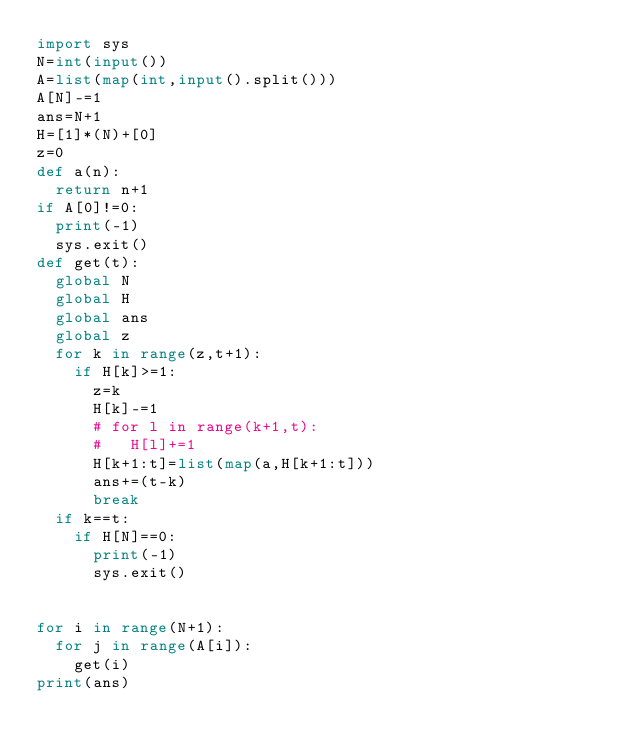<code> <loc_0><loc_0><loc_500><loc_500><_Python_>import sys
N=int(input())
A=list(map(int,input().split()))
A[N]-=1
ans=N+1
H=[1]*(N)+[0]
z=0
def a(n):
  return n+1
if A[0]!=0:
  print(-1)
  sys.exit()
def get(t):
  global N
  global H
  global ans
  global z
  for k in range(z,t+1):
    if H[k]>=1:
      z=k
      H[k]-=1
      # for l in range(k+1,t):
      #   H[l]+=1
      H[k+1:t]=list(map(a,H[k+1:t]))
      ans+=(t-k)
      break
  if k==t:
    if H[N]==0:
      print(-1)
      sys.exit()


for i in range(N+1):
  for j in range(A[i]):
    get(i)
print(ans)
</code> 